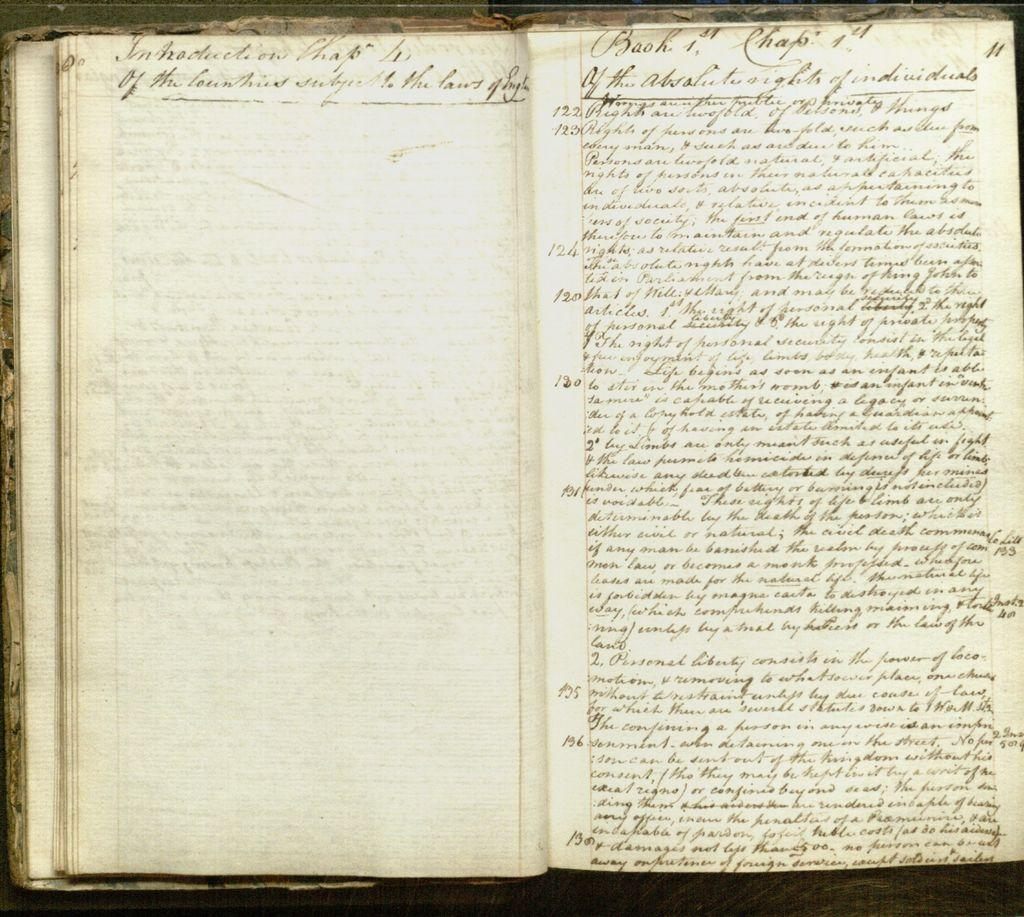Provide a one-sentence caption for the provided image. a series of things written on a book with the word 'book' written at the top. 